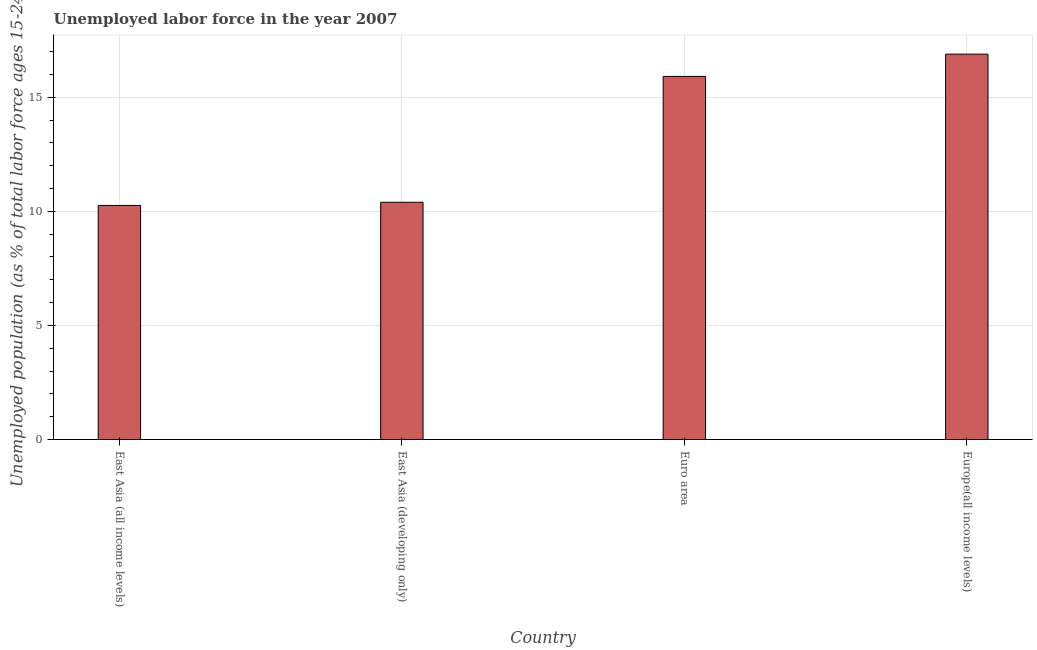Does the graph contain any zero values?
Your answer should be very brief. No. What is the title of the graph?
Keep it short and to the point. Unemployed labor force in the year 2007. What is the label or title of the Y-axis?
Provide a succinct answer. Unemployed population (as % of total labor force ages 15-24). What is the total unemployed youth population in Euro area?
Provide a short and direct response. 15.91. Across all countries, what is the maximum total unemployed youth population?
Provide a succinct answer. 16.89. Across all countries, what is the minimum total unemployed youth population?
Ensure brevity in your answer.  10.26. In which country was the total unemployed youth population maximum?
Provide a succinct answer. Europe(all income levels). In which country was the total unemployed youth population minimum?
Provide a succinct answer. East Asia (all income levels). What is the sum of the total unemployed youth population?
Provide a short and direct response. 53.46. What is the difference between the total unemployed youth population in East Asia (developing only) and Euro area?
Offer a terse response. -5.51. What is the average total unemployed youth population per country?
Offer a terse response. 13.36. What is the median total unemployed youth population?
Your response must be concise. 13.15. What is the ratio of the total unemployed youth population in East Asia (all income levels) to that in Euro area?
Offer a very short reply. 0.65. Is the total unemployed youth population in East Asia (all income levels) less than that in Europe(all income levels)?
Offer a terse response. Yes. Is the difference between the total unemployed youth population in East Asia (all income levels) and East Asia (developing only) greater than the difference between any two countries?
Offer a very short reply. No. What is the difference between the highest and the second highest total unemployed youth population?
Provide a succinct answer. 0.98. Is the sum of the total unemployed youth population in East Asia (all income levels) and Europe(all income levels) greater than the maximum total unemployed youth population across all countries?
Provide a short and direct response. Yes. What is the difference between the highest and the lowest total unemployed youth population?
Make the answer very short. 6.63. In how many countries, is the total unemployed youth population greater than the average total unemployed youth population taken over all countries?
Offer a terse response. 2. Are all the bars in the graph horizontal?
Ensure brevity in your answer.  No. Are the values on the major ticks of Y-axis written in scientific E-notation?
Give a very brief answer. No. What is the Unemployed population (as % of total labor force ages 15-24) in East Asia (all income levels)?
Offer a very short reply. 10.26. What is the Unemployed population (as % of total labor force ages 15-24) of East Asia (developing only)?
Offer a very short reply. 10.4. What is the Unemployed population (as % of total labor force ages 15-24) of Euro area?
Give a very brief answer. 15.91. What is the Unemployed population (as % of total labor force ages 15-24) in Europe(all income levels)?
Keep it short and to the point. 16.89. What is the difference between the Unemployed population (as % of total labor force ages 15-24) in East Asia (all income levels) and East Asia (developing only)?
Offer a very short reply. -0.14. What is the difference between the Unemployed population (as % of total labor force ages 15-24) in East Asia (all income levels) and Euro area?
Offer a very short reply. -5.65. What is the difference between the Unemployed population (as % of total labor force ages 15-24) in East Asia (all income levels) and Europe(all income levels)?
Make the answer very short. -6.63. What is the difference between the Unemployed population (as % of total labor force ages 15-24) in East Asia (developing only) and Euro area?
Provide a short and direct response. -5.52. What is the difference between the Unemployed population (as % of total labor force ages 15-24) in East Asia (developing only) and Europe(all income levels)?
Your answer should be very brief. -6.49. What is the difference between the Unemployed population (as % of total labor force ages 15-24) in Euro area and Europe(all income levels)?
Provide a short and direct response. -0.98. What is the ratio of the Unemployed population (as % of total labor force ages 15-24) in East Asia (all income levels) to that in Euro area?
Your answer should be compact. 0.65. What is the ratio of the Unemployed population (as % of total labor force ages 15-24) in East Asia (all income levels) to that in Europe(all income levels)?
Make the answer very short. 0.61. What is the ratio of the Unemployed population (as % of total labor force ages 15-24) in East Asia (developing only) to that in Euro area?
Make the answer very short. 0.65. What is the ratio of the Unemployed population (as % of total labor force ages 15-24) in East Asia (developing only) to that in Europe(all income levels)?
Provide a short and direct response. 0.62. What is the ratio of the Unemployed population (as % of total labor force ages 15-24) in Euro area to that in Europe(all income levels)?
Your answer should be compact. 0.94. 